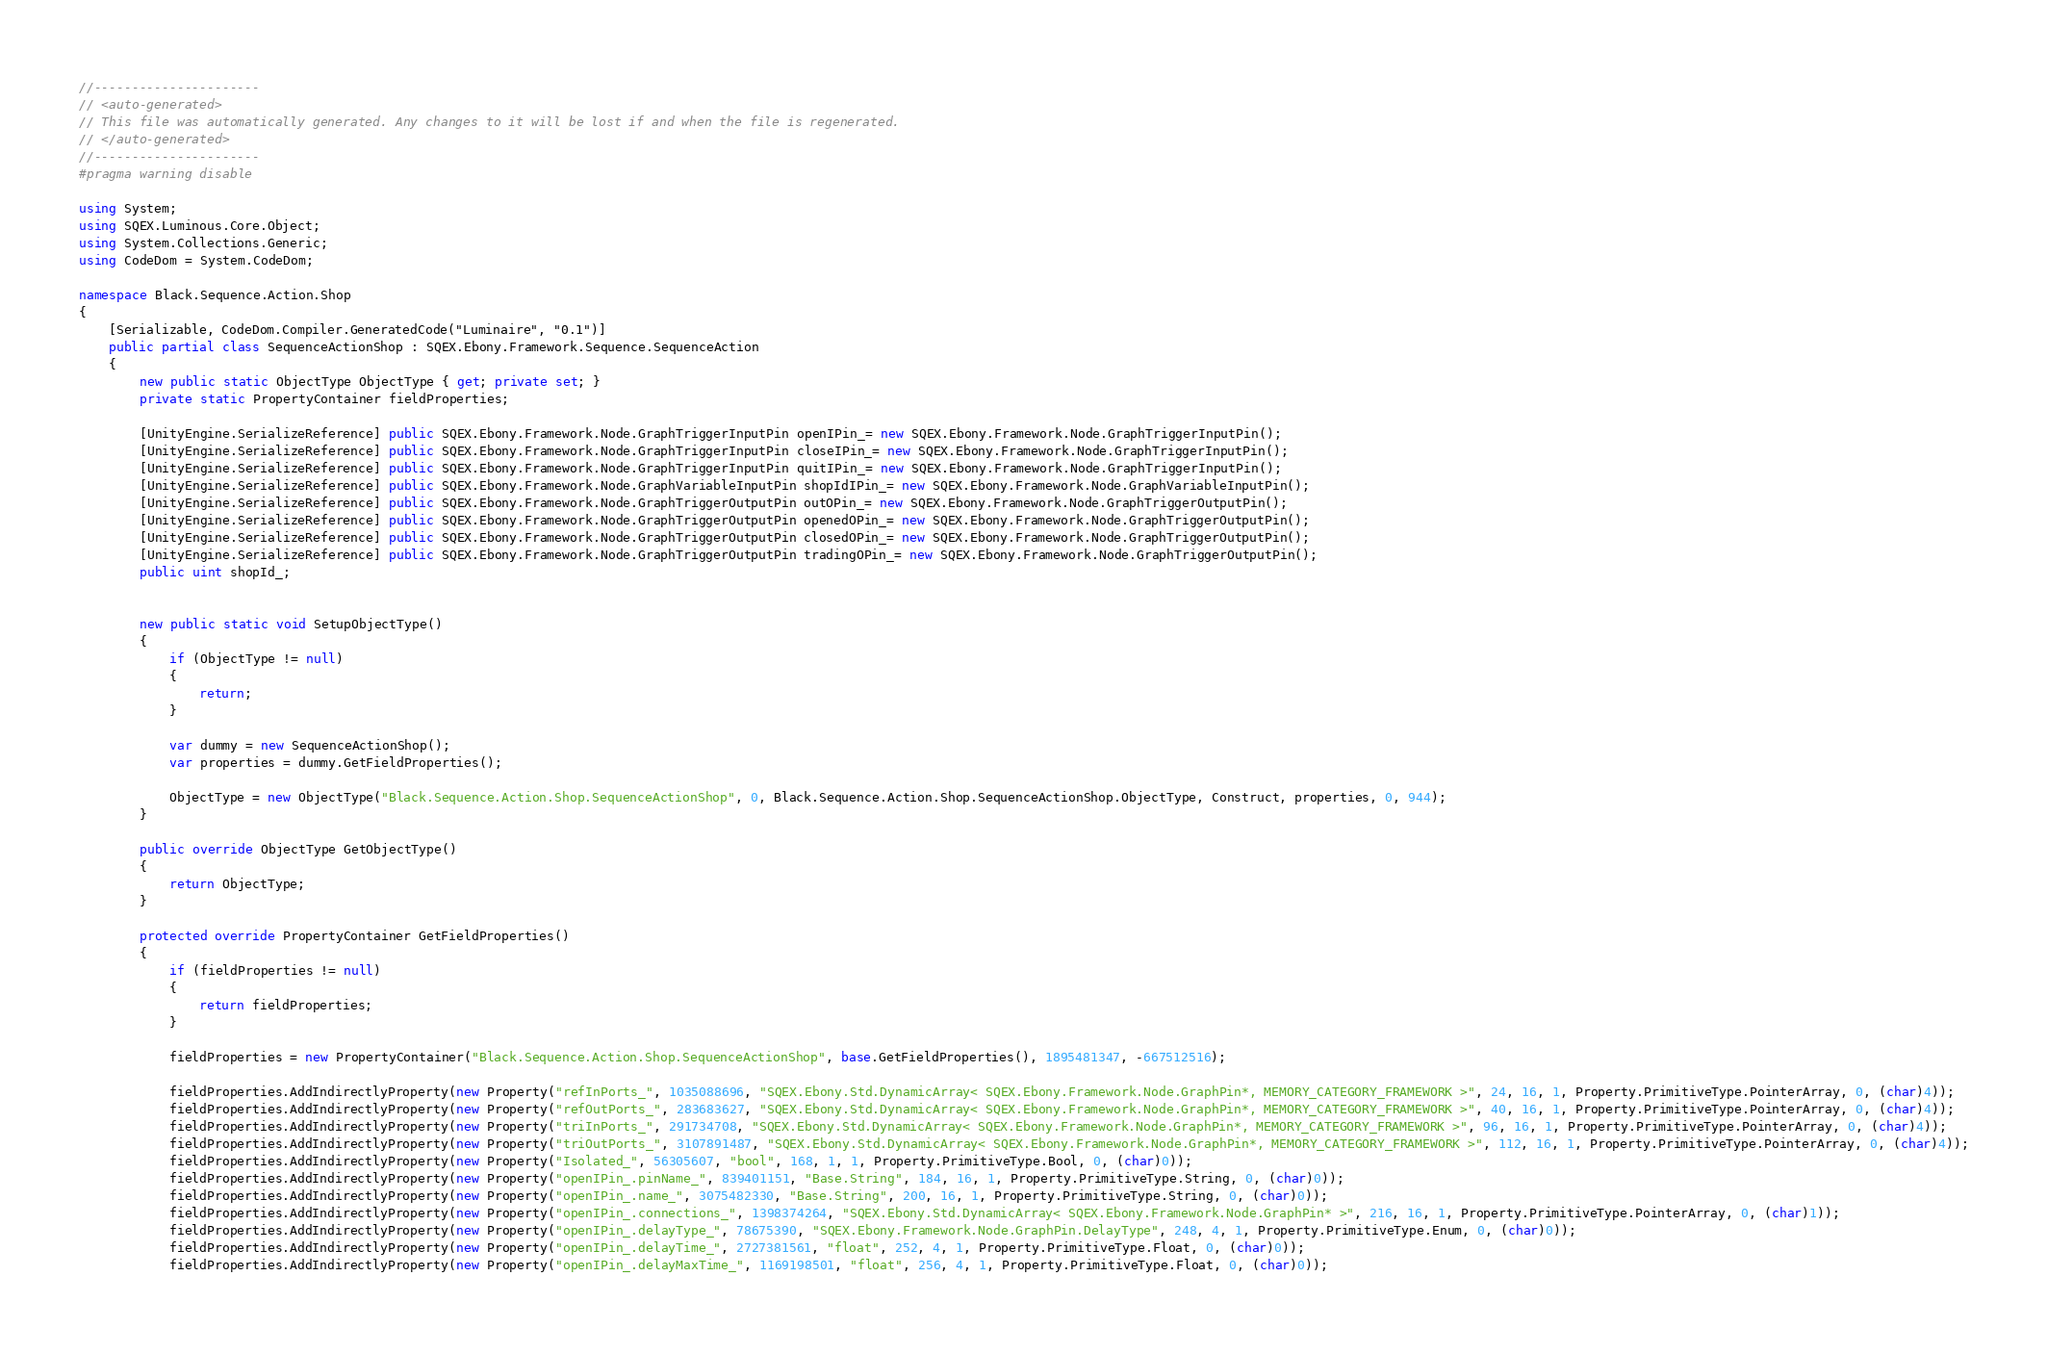<code> <loc_0><loc_0><loc_500><loc_500><_C#_>//----------------------
// <auto-generated>
// This file was automatically generated. Any changes to it will be lost if and when the file is regenerated.
// </auto-generated>
//----------------------
#pragma warning disable

using System;
using SQEX.Luminous.Core.Object;
using System.Collections.Generic;
using CodeDom = System.CodeDom;

namespace Black.Sequence.Action.Shop
{
    [Serializable, CodeDom.Compiler.GeneratedCode("Luminaire", "0.1")]
    public partial class SequenceActionShop : SQEX.Ebony.Framework.Sequence.SequenceAction
    {
        new public static ObjectType ObjectType { get; private set; }
        private static PropertyContainer fieldProperties;
		
		[UnityEngine.SerializeReference] public SQEX.Ebony.Framework.Node.GraphTriggerInputPin openIPin_= new SQEX.Ebony.Framework.Node.GraphTriggerInputPin();
		[UnityEngine.SerializeReference] public SQEX.Ebony.Framework.Node.GraphTriggerInputPin closeIPin_= new SQEX.Ebony.Framework.Node.GraphTriggerInputPin();
		[UnityEngine.SerializeReference] public SQEX.Ebony.Framework.Node.GraphTriggerInputPin quitIPin_= new SQEX.Ebony.Framework.Node.GraphTriggerInputPin();
		[UnityEngine.SerializeReference] public SQEX.Ebony.Framework.Node.GraphVariableInputPin shopIdIPin_= new SQEX.Ebony.Framework.Node.GraphVariableInputPin();
		[UnityEngine.SerializeReference] public SQEX.Ebony.Framework.Node.GraphTriggerOutputPin outOPin_= new SQEX.Ebony.Framework.Node.GraphTriggerOutputPin();
		[UnityEngine.SerializeReference] public SQEX.Ebony.Framework.Node.GraphTriggerOutputPin openedOPin_= new SQEX.Ebony.Framework.Node.GraphTriggerOutputPin();
		[UnityEngine.SerializeReference] public SQEX.Ebony.Framework.Node.GraphTriggerOutputPin closedOPin_= new SQEX.Ebony.Framework.Node.GraphTriggerOutputPin();
		[UnityEngine.SerializeReference] public SQEX.Ebony.Framework.Node.GraphTriggerOutputPin tradingOPin_= new SQEX.Ebony.Framework.Node.GraphTriggerOutputPin();
		public uint shopId_;
		
        
        new public static void SetupObjectType()
        {
            if (ObjectType != null)
            {
                return;
            }

            var dummy = new SequenceActionShop();
            var properties = dummy.GetFieldProperties();

            ObjectType = new ObjectType("Black.Sequence.Action.Shop.SequenceActionShop", 0, Black.Sequence.Action.Shop.SequenceActionShop.ObjectType, Construct, properties, 0, 944);
        }
		
        public override ObjectType GetObjectType()
        {
            return ObjectType;
        }

        protected override PropertyContainer GetFieldProperties()
        {
            if (fieldProperties != null)
            {
                return fieldProperties;
            }

            fieldProperties = new PropertyContainer("Black.Sequence.Action.Shop.SequenceActionShop", base.GetFieldProperties(), 1895481347, -667512516);
            
			fieldProperties.AddIndirectlyProperty(new Property("refInPorts_", 1035088696, "SQEX.Ebony.Std.DynamicArray< SQEX.Ebony.Framework.Node.GraphPin*, MEMORY_CATEGORY_FRAMEWORK >", 24, 16, 1, Property.PrimitiveType.PointerArray, 0, (char)4));
			fieldProperties.AddIndirectlyProperty(new Property("refOutPorts_", 283683627, "SQEX.Ebony.Std.DynamicArray< SQEX.Ebony.Framework.Node.GraphPin*, MEMORY_CATEGORY_FRAMEWORK >", 40, 16, 1, Property.PrimitiveType.PointerArray, 0, (char)4));
			fieldProperties.AddIndirectlyProperty(new Property("triInPorts_", 291734708, "SQEX.Ebony.Std.DynamicArray< SQEX.Ebony.Framework.Node.GraphPin*, MEMORY_CATEGORY_FRAMEWORK >", 96, 16, 1, Property.PrimitiveType.PointerArray, 0, (char)4));
			fieldProperties.AddIndirectlyProperty(new Property("triOutPorts_", 3107891487, "SQEX.Ebony.Std.DynamicArray< SQEX.Ebony.Framework.Node.GraphPin*, MEMORY_CATEGORY_FRAMEWORK >", 112, 16, 1, Property.PrimitiveType.PointerArray, 0, (char)4));
			fieldProperties.AddIndirectlyProperty(new Property("Isolated_", 56305607, "bool", 168, 1, 1, Property.PrimitiveType.Bool, 0, (char)0));
			fieldProperties.AddIndirectlyProperty(new Property("openIPin_.pinName_", 839401151, "Base.String", 184, 16, 1, Property.PrimitiveType.String, 0, (char)0));
			fieldProperties.AddIndirectlyProperty(new Property("openIPin_.name_", 3075482330, "Base.String", 200, 16, 1, Property.PrimitiveType.String, 0, (char)0));
			fieldProperties.AddIndirectlyProperty(new Property("openIPin_.connections_", 1398374264, "SQEX.Ebony.Std.DynamicArray< SQEX.Ebony.Framework.Node.GraphPin* >", 216, 16, 1, Property.PrimitiveType.PointerArray, 0, (char)1));
			fieldProperties.AddIndirectlyProperty(new Property("openIPin_.delayType_", 78675390, "SQEX.Ebony.Framework.Node.GraphPin.DelayType", 248, 4, 1, Property.PrimitiveType.Enum, 0, (char)0));
			fieldProperties.AddIndirectlyProperty(new Property("openIPin_.delayTime_", 2727381561, "float", 252, 4, 1, Property.PrimitiveType.Float, 0, (char)0));
			fieldProperties.AddIndirectlyProperty(new Property("openIPin_.delayMaxTime_", 1169198501, "float", 256, 4, 1, Property.PrimitiveType.Float, 0, (char)0));</code> 